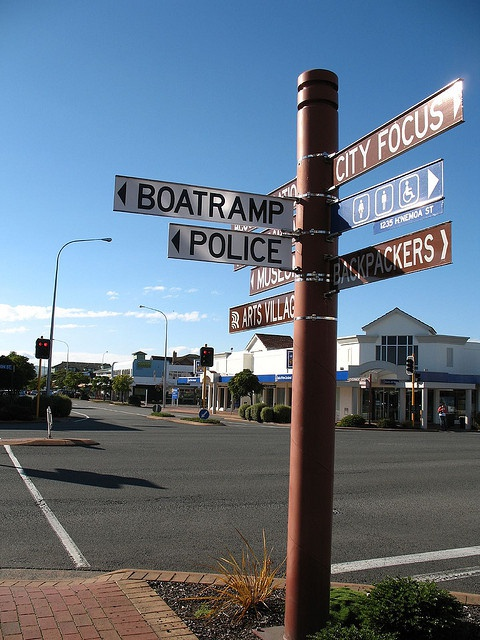Describe the objects in this image and their specific colors. I can see traffic light in gray, black, maroon, and brown tones, traffic light in gray, black, maroon, and purple tones, people in gray, black, maroon, and brown tones, traffic light in gray, black, lightgray, and darkgray tones, and traffic light in gray, black, and darkgray tones in this image. 